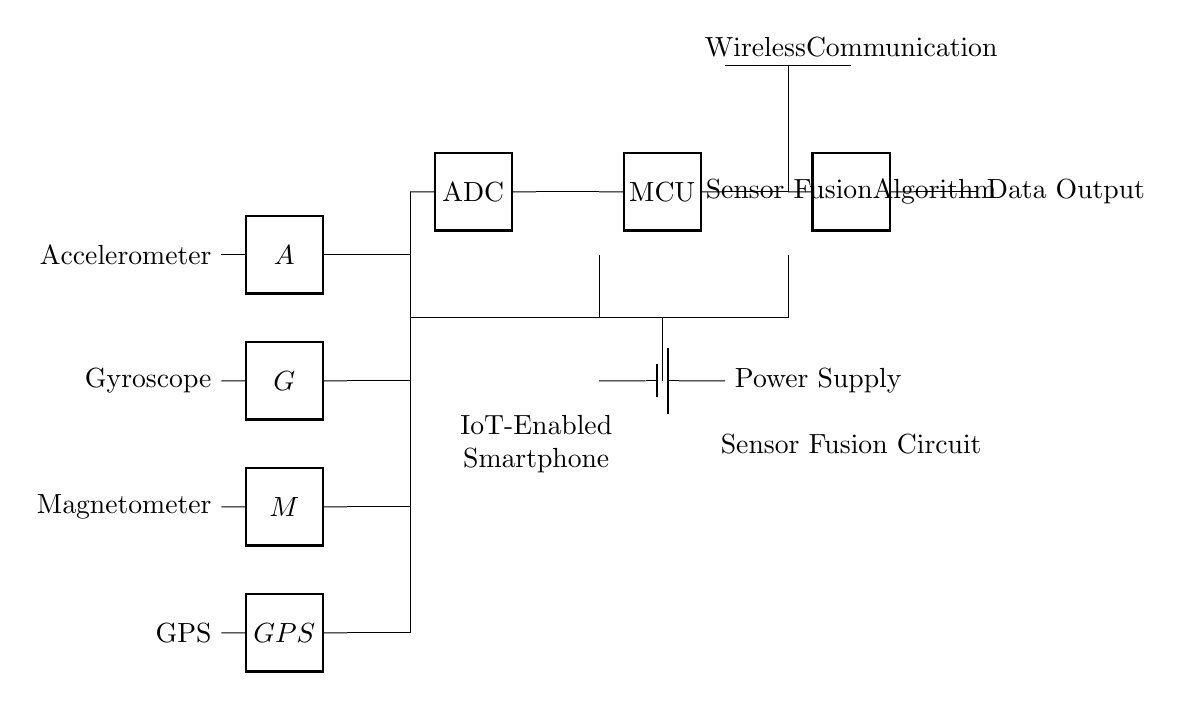What sensors are included in this circuit? The circuit features an accelerometer, gyroscope, magnetometer, and GPS as indicated by the labels next to each two-port component in the diagram.
Answer: Accelerometer, gyroscope, magnetometer, GPS What is the function of the ADC in this circuit? The Analog-to-Digital Converter (ADC) is responsible for converting the analog signals from the sensors into digital data, as it is connected to the outputs of the sensors and sends data to the microcontroller.
Answer: Data conversion Which component provides power to the circuit? The circuit diagram shows a battery symbol connected to the components, indicating that the power supply is from a battery which is evident in the connection to the microcontroller and the ADC.
Answer: Battery What type of algorithm is implemented in this circuit? The circuit label identifies a 'Sensor Fusion Algorithm,' which implies the algorithm's purpose is to combine the data from various sensors to create a cohesive output.
Answer: Sensor Fusion Algorithm What is the role of the wireless communication component in this circuit? The wireless communication part is connected to the output of the sensor fusion algorithm, allowing the smartphone to transmit the processed data to other devices or systems.
Answer: Data transmission How many sensor inputs does the microcontroller handle? The microcontroller receives inputs from four different sensors, indicated by the connections from the ADC starting from each sensor's output.
Answer: Four sensor inputs Where does the data output originate from in this circuit? The data output comes from the sensor fusion algorithm, which is clearly indicated as the final component connected to the output pathway leading to data output.
Answer: Sensor Fusion Algorithm 